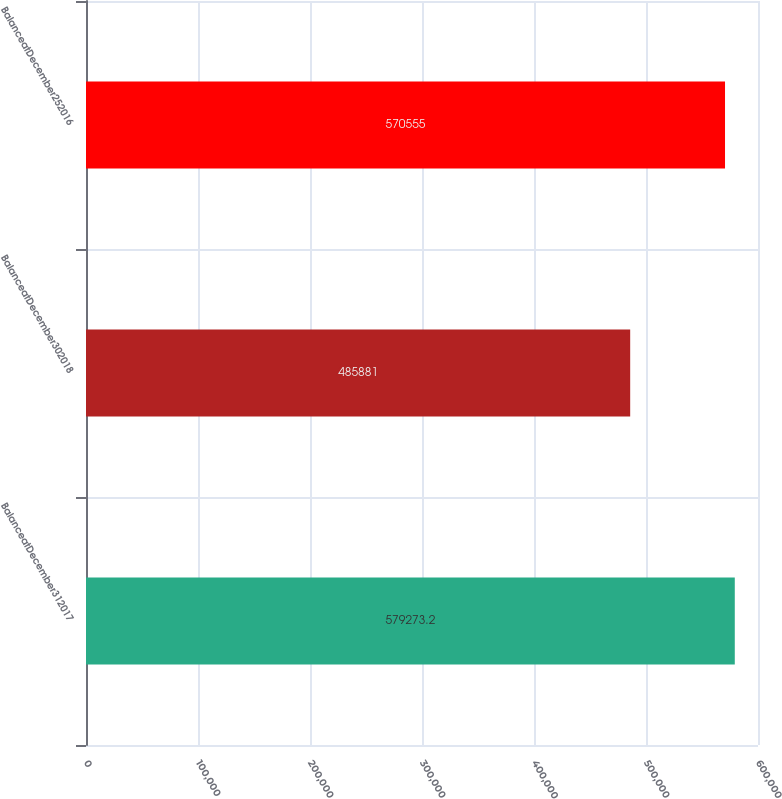Convert chart to OTSL. <chart><loc_0><loc_0><loc_500><loc_500><bar_chart><fcel>BalanceatDecember312017<fcel>BalanceatDecember302018<fcel>BalanceatDecember252016<nl><fcel>579273<fcel>485881<fcel>570555<nl></chart> 